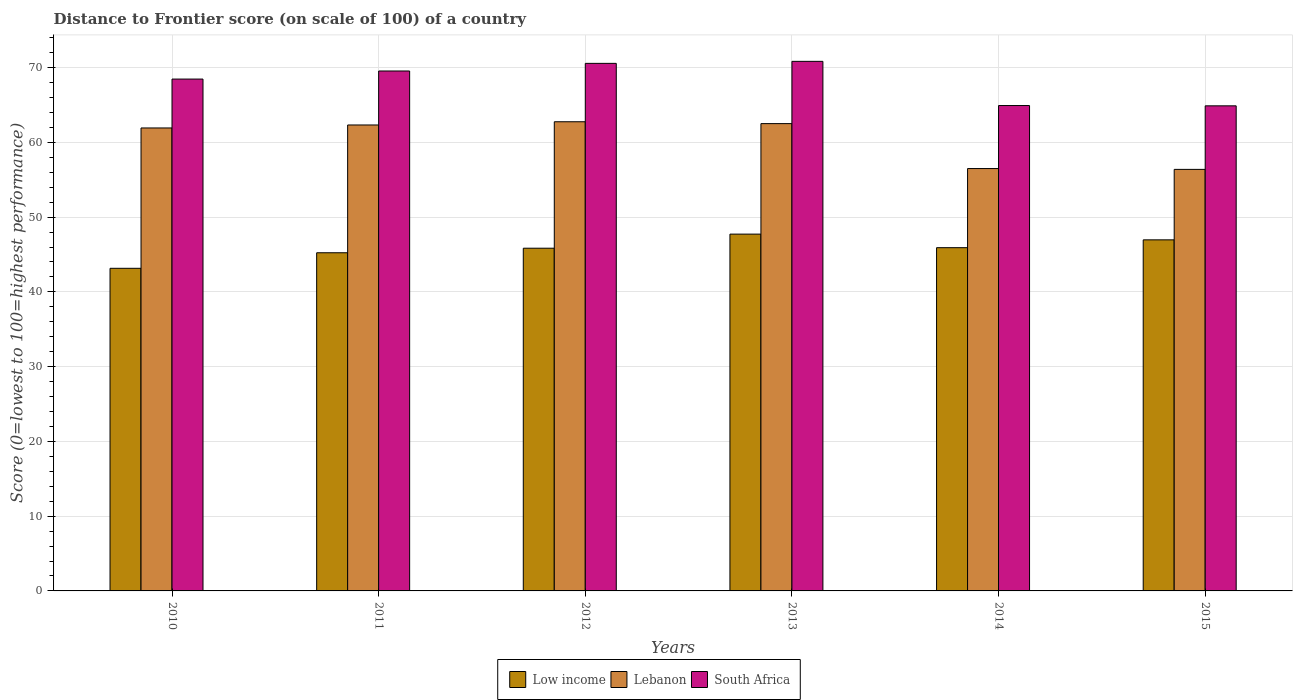How many groups of bars are there?
Keep it short and to the point. 6. How many bars are there on the 2nd tick from the left?
Offer a terse response. 3. How many bars are there on the 5th tick from the right?
Your answer should be compact. 3. What is the label of the 2nd group of bars from the left?
Your answer should be compact. 2011. What is the distance to frontier score of in South Africa in 2012?
Make the answer very short. 70.57. Across all years, what is the maximum distance to frontier score of in South Africa?
Give a very brief answer. 70.84. Across all years, what is the minimum distance to frontier score of in Low income?
Your answer should be compact. 43.16. In which year was the distance to frontier score of in Lebanon minimum?
Offer a terse response. 2015. What is the total distance to frontier score of in Low income in the graph?
Your response must be concise. 274.84. What is the difference between the distance to frontier score of in Low income in 2010 and that in 2012?
Ensure brevity in your answer.  -2.69. What is the difference between the distance to frontier score of in South Africa in 2011 and the distance to frontier score of in Lebanon in 2014?
Your answer should be very brief. 13.05. What is the average distance to frontier score of in Low income per year?
Your answer should be compact. 45.81. In the year 2014, what is the difference between the distance to frontier score of in Lebanon and distance to frontier score of in South Africa?
Keep it short and to the point. -8.43. What is the ratio of the distance to frontier score of in Low income in 2012 to that in 2015?
Give a very brief answer. 0.98. What is the difference between the highest and the lowest distance to frontier score of in Low income?
Offer a terse response. 4.57. What does the 3rd bar from the left in 2012 represents?
Offer a very short reply. South Africa. What does the 1st bar from the right in 2011 represents?
Give a very brief answer. South Africa. How many bars are there?
Provide a short and direct response. 18. Are all the bars in the graph horizontal?
Provide a short and direct response. No. Are the values on the major ticks of Y-axis written in scientific E-notation?
Your response must be concise. No. How many legend labels are there?
Your response must be concise. 3. How are the legend labels stacked?
Make the answer very short. Horizontal. What is the title of the graph?
Make the answer very short. Distance to Frontier score (on scale of 100) of a country. Does "Croatia" appear as one of the legend labels in the graph?
Ensure brevity in your answer.  No. What is the label or title of the Y-axis?
Your answer should be compact. Score (0=lowest to 100=highest performance). What is the Score (0=lowest to 100=highest performance) of Low income in 2010?
Ensure brevity in your answer.  43.16. What is the Score (0=lowest to 100=highest performance) in Lebanon in 2010?
Keep it short and to the point. 61.93. What is the Score (0=lowest to 100=highest performance) in South Africa in 2010?
Provide a succinct answer. 68.47. What is the Score (0=lowest to 100=highest performance) of Low income in 2011?
Provide a short and direct response. 45.24. What is the Score (0=lowest to 100=highest performance) in Lebanon in 2011?
Your response must be concise. 62.33. What is the Score (0=lowest to 100=highest performance) of South Africa in 2011?
Your answer should be very brief. 69.55. What is the Score (0=lowest to 100=highest performance) in Low income in 2012?
Keep it short and to the point. 45.84. What is the Score (0=lowest to 100=highest performance) of Lebanon in 2012?
Give a very brief answer. 62.76. What is the Score (0=lowest to 100=highest performance) in South Africa in 2012?
Offer a terse response. 70.57. What is the Score (0=lowest to 100=highest performance) of Low income in 2013?
Offer a very short reply. 47.73. What is the Score (0=lowest to 100=highest performance) of Lebanon in 2013?
Ensure brevity in your answer.  62.51. What is the Score (0=lowest to 100=highest performance) in South Africa in 2013?
Your response must be concise. 70.84. What is the Score (0=lowest to 100=highest performance) in Low income in 2014?
Your response must be concise. 45.92. What is the Score (0=lowest to 100=highest performance) of Lebanon in 2014?
Provide a short and direct response. 56.5. What is the Score (0=lowest to 100=highest performance) of South Africa in 2014?
Provide a succinct answer. 64.93. What is the Score (0=lowest to 100=highest performance) in Low income in 2015?
Provide a short and direct response. 46.96. What is the Score (0=lowest to 100=highest performance) in Lebanon in 2015?
Provide a succinct answer. 56.39. What is the Score (0=lowest to 100=highest performance) in South Africa in 2015?
Your answer should be very brief. 64.89. Across all years, what is the maximum Score (0=lowest to 100=highest performance) of Low income?
Ensure brevity in your answer.  47.73. Across all years, what is the maximum Score (0=lowest to 100=highest performance) in Lebanon?
Offer a terse response. 62.76. Across all years, what is the maximum Score (0=lowest to 100=highest performance) of South Africa?
Give a very brief answer. 70.84. Across all years, what is the minimum Score (0=lowest to 100=highest performance) in Low income?
Your answer should be very brief. 43.16. Across all years, what is the minimum Score (0=lowest to 100=highest performance) of Lebanon?
Your response must be concise. 56.39. Across all years, what is the minimum Score (0=lowest to 100=highest performance) in South Africa?
Provide a succinct answer. 64.89. What is the total Score (0=lowest to 100=highest performance) of Low income in the graph?
Your response must be concise. 274.84. What is the total Score (0=lowest to 100=highest performance) of Lebanon in the graph?
Your response must be concise. 362.42. What is the total Score (0=lowest to 100=highest performance) in South Africa in the graph?
Offer a terse response. 409.25. What is the difference between the Score (0=lowest to 100=highest performance) of Low income in 2010 and that in 2011?
Offer a terse response. -2.08. What is the difference between the Score (0=lowest to 100=highest performance) in South Africa in 2010 and that in 2011?
Provide a succinct answer. -1.08. What is the difference between the Score (0=lowest to 100=highest performance) in Low income in 2010 and that in 2012?
Your answer should be very brief. -2.69. What is the difference between the Score (0=lowest to 100=highest performance) of Lebanon in 2010 and that in 2012?
Your answer should be compact. -0.83. What is the difference between the Score (0=lowest to 100=highest performance) in South Africa in 2010 and that in 2012?
Your response must be concise. -2.1. What is the difference between the Score (0=lowest to 100=highest performance) of Low income in 2010 and that in 2013?
Make the answer very short. -4.57. What is the difference between the Score (0=lowest to 100=highest performance) in Lebanon in 2010 and that in 2013?
Keep it short and to the point. -0.58. What is the difference between the Score (0=lowest to 100=highest performance) in South Africa in 2010 and that in 2013?
Provide a succinct answer. -2.37. What is the difference between the Score (0=lowest to 100=highest performance) in Low income in 2010 and that in 2014?
Provide a succinct answer. -2.76. What is the difference between the Score (0=lowest to 100=highest performance) of Lebanon in 2010 and that in 2014?
Your answer should be compact. 5.43. What is the difference between the Score (0=lowest to 100=highest performance) of South Africa in 2010 and that in 2014?
Your answer should be compact. 3.54. What is the difference between the Score (0=lowest to 100=highest performance) in Low income in 2010 and that in 2015?
Your response must be concise. -3.81. What is the difference between the Score (0=lowest to 100=highest performance) of Lebanon in 2010 and that in 2015?
Provide a succinct answer. 5.54. What is the difference between the Score (0=lowest to 100=highest performance) of South Africa in 2010 and that in 2015?
Give a very brief answer. 3.58. What is the difference between the Score (0=lowest to 100=highest performance) of Low income in 2011 and that in 2012?
Offer a terse response. -0.61. What is the difference between the Score (0=lowest to 100=highest performance) in Lebanon in 2011 and that in 2012?
Offer a very short reply. -0.43. What is the difference between the Score (0=lowest to 100=highest performance) in South Africa in 2011 and that in 2012?
Offer a very short reply. -1.02. What is the difference between the Score (0=lowest to 100=highest performance) in Low income in 2011 and that in 2013?
Your answer should be very brief. -2.49. What is the difference between the Score (0=lowest to 100=highest performance) of Lebanon in 2011 and that in 2013?
Your response must be concise. -0.18. What is the difference between the Score (0=lowest to 100=highest performance) in South Africa in 2011 and that in 2013?
Your answer should be very brief. -1.29. What is the difference between the Score (0=lowest to 100=highest performance) in Low income in 2011 and that in 2014?
Keep it short and to the point. -0.68. What is the difference between the Score (0=lowest to 100=highest performance) of Lebanon in 2011 and that in 2014?
Provide a short and direct response. 5.83. What is the difference between the Score (0=lowest to 100=highest performance) of South Africa in 2011 and that in 2014?
Provide a succinct answer. 4.62. What is the difference between the Score (0=lowest to 100=highest performance) in Low income in 2011 and that in 2015?
Your answer should be very brief. -1.73. What is the difference between the Score (0=lowest to 100=highest performance) in Lebanon in 2011 and that in 2015?
Offer a terse response. 5.94. What is the difference between the Score (0=lowest to 100=highest performance) in South Africa in 2011 and that in 2015?
Ensure brevity in your answer.  4.66. What is the difference between the Score (0=lowest to 100=highest performance) of Low income in 2012 and that in 2013?
Keep it short and to the point. -1.89. What is the difference between the Score (0=lowest to 100=highest performance) of Lebanon in 2012 and that in 2013?
Your answer should be compact. 0.25. What is the difference between the Score (0=lowest to 100=highest performance) in South Africa in 2012 and that in 2013?
Offer a very short reply. -0.27. What is the difference between the Score (0=lowest to 100=highest performance) of Low income in 2012 and that in 2014?
Provide a succinct answer. -0.07. What is the difference between the Score (0=lowest to 100=highest performance) of Lebanon in 2012 and that in 2014?
Keep it short and to the point. 6.26. What is the difference between the Score (0=lowest to 100=highest performance) in South Africa in 2012 and that in 2014?
Your response must be concise. 5.64. What is the difference between the Score (0=lowest to 100=highest performance) of Low income in 2012 and that in 2015?
Offer a terse response. -1.12. What is the difference between the Score (0=lowest to 100=highest performance) of Lebanon in 2012 and that in 2015?
Your answer should be compact. 6.37. What is the difference between the Score (0=lowest to 100=highest performance) in South Africa in 2012 and that in 2015?
Your answer should be very brief. 5.68. What is the difference between the Score (0=lowest to 100=highest performance) of Low income in 2013 and that in 2014?
Your answer should be very brief. 1.81. What is the difference between the Score (0=lowest to 100=highest performance) of Lebanon in 2013 and that in 2014?
Provide a succinct answer. 6.01. What is the difference between the Score (0=lowest to 100=highest performance) of South Africa in 2013 and that in 2014?
Offer a terse response. 5.91. What is the difference between the Score (0=lowest to 100=highest performance) in Low income in 2013 and that in 2015?
Provide a succinct answer. 0.77. What is the difference between the Score (0=lowest to 100=highest performance) in Lebanon in 2013 and that in 2015?
Provide a succinct answer. 6.12. What is the difference between the Score (0=lowest to 100=highest performance) in South Africa in 2013 and that in 2015?
Give a very brief answer. 5.95. What is the difference between the Score (0=lowest to 100=highest performance) in Low income in 2014 and that in 2015?
Your answer should be compact. -1.05. What is the difference between the Score (0=lowest to 100=highest performance) in Lebanon in 2014 and that in 2015?
Your answer should be very brief. 0.11. What is the difference between the Score (0=lowest to 100=highest performance) of South Africa in 2014 and that in 2015?
Your answer should be very brief. 0.04. What is the difference between the Score (0=lowest to 100=highest performance) of Low income in 2010 and the Score (0=lowest to 100=highest performance) of Lebanon in 2011?
Offer a very short reply. -19.17. What is the difference between the Score (0=lowest to 100=highest performance) of Low income in 2010 and the Score (0=lowest to 100=highest performance) of South Africa in 2011?
Your answer should be compact. -26.39. What is the difference between the Score (0=lowest to 100=highest performance) in Lebanon in 2010 and the Score (0=lowest to 100=highest performance) in South Africa in 2011?
Ensure brevity in your answer.  -7.62. What is the difference between the Score (0=lowest to 100=highest performance) of Low income in 2010 and the Score (0=lowest to 100=highest performance) of Lebanon in 2012?
Ensure brevity in your answer.  -19.6. What is the difference between the Score (0=lowest to 100=highest performance) of Low income in 2010 and the Score (0=lowest to 100=highest performance) of South Africa in 2012?
Make the answer very short. -27.41. What is the difference between the Score (0=lowest to 100=highest performance) in Lebanon in 2010 and the Score (0=lowest to 100=highest performance) in South Africa in 2012?
Make the answer very short. -8.64. What is the difference between the Score (0=lowest to 100=highest performance) in Low income in 2010 and the Score (0=lowest to 100=highest performance) in Lebanon in 2013?
Your answer should be compact. -19.35. What is the difference between the Score (0=lowest to 100=highest performance) of Low income in 2010 and the Score (0=lowest to 100=highest performance) of South Africa in 2013?
Your answer should be very brief. -27.68. What is the difference between the Score (0=lowest to 100=highest performance) of Lebanon in 2010 and the Score (0=lowest to 100=highest performance) of South Africa in 2013?
Your response must be concise. -8.91. What is the difference between the Score (0=lowest to 100=highest performance) in Low income in 2010 and the Score (0=lowest to 100=highest performance) in Lebanon in 2014?
Your response must be concise. -13.34. What is the difference between the Score (0=lowest to 100=highest performance) of Low income in 2010 and the Score (0=lowest to 100=highest performance) of South Africa in 2014?
Your answer should be very brief. -21.77. What is the difference between the Score (0=lowest to 100=highest performance) of Lebanon in 2010 and the Score (0=lowest to 100=highest performance) of South Africa in 2014?
Your answer should be compact. -3. What is the difference between the Score (0=lowest to 100=highest performance) of Low income in 2010 and the Score (0=lowest to 100=highest performance) of Lebanon in 2015?
Make the answer very short. -13.23. What is the difference between the Score (0=lowest to 100=highest performance) in Low income in 2010 and the Score (0=lowest to 100=highest performance) in South Africa in 2015?
Your response must be concise. -21.73. What is the difference between the Score (0=lowest to 100=highest performance) in Lebanon in 2010 and the Score (0=lowest to 100=highest performance) in South Africa in 2015?
Your response must be concise. -2.96. What is the difference between the Score (0=lowest to 100=highest performance) of Low income in 2011 and the Score (0=lowest to 100=highest performance) of Lebanon in 2012?
Offer a very short reply. -17.52. What is the difference between the Score (0=lowest to 100=highest performance) of Low income in 2011 and the Score (0=lowest to 100=highest performance) of South Africa in 2012?
Provide a short and direct response. -25.33. What is the difference between the Score (0=lowest to 100=highest performance) of Lebanon in 2011 and the Score (0=lowest to 100=highest performance) of South Africa in 2012?
Keep it short and to the point. -8.24. What is the difference between the Score (0=lowest to 100=highest performance) in Low income in 2011 and the Score (0=lowest to 100=highest performance) in Lebanon in 2013?
Keep it short and to the point. -17.27. What is the difference between the Score (0=lowest to 100=highest performance) in Low income in 2011 and the Score (0=lowest to 100=highest performance) in South Africa in 2013?
Your answer should be compact. -25.6. What is the difference between the Score (0=lowest to 100=highest performance) in Lebanon in 2011 and the Score (0=lowest to 100=highest performance) in South Africa in 2013?
Keep it short and to the point. -8.51. What is the difference between the Score (0=lowest to 100=highest performance) in Low income in 2011 and the Score (0=lowest to 100=highest performance) in Lebanon in 2014?
Offer a terse response. -11.26. What is the difference between the Score (0=lowest to 100=highest performance) in Low income in 2011 and the Score (0=lowest to 100=highest performance) in South Africa in 2014?
Provide a succinct answer. -19.69. What is the difference between the Score (0=lowest to 100=highest performance) of Lebanon in 2011 and the Score (0=lowest to 100=highest performance) of South Africa in 2014?
Your response must be concise. -2.6. What is the difference between the Score (0=lowest to 100=highest performance) of Low income in 2011 and the Score (0=lowest to 100=highest performance) of Lebanon in 2015?
Your answer should be compact. -11.15. What is the difference between the Score (0=lowest to 100=highest performance) of Low income in 2011 and the Score (0=lowest to 100=highest performance) of South Africa in 2015?
Provide a succinct answer. -19.65. What is the difference between the Score (0=lowest to 100=highest performance) of Lebanon in 2011 and the Score (0=lowest to 100=highest performance) of South Africa in 2015?
Keep it short and to the point. -2.56. What is the difference between the Score (0=lowest to 100=highest performance) in Low income in 2012 and the Score (0=lowest to 100=highest performance) in Lebanon in 2013?
Offer a very short reply. -16.67. What is the difference between the Score (0=lowest to 100=highest performance) of Low income in 2012 and the Score (0=lowest to 100=highest performance) of South Africa in 2013?
Give a very brief answer. -25. What is the difference between the Score (0=lowest to 100=highest performance) of Lebanon in 2012 and the Score (0=lowest to 100=highest performance) of South Africa in 2013?
Keep it short and to the point. -8.08. What is the difference between the Score (0=lowest to 100=highest performance) in Low income in 2012 and the Score (0=lowest to 100=highest performance) in Lebanon in 2014?
Keep it short and to the point. -10.66. What is the difference between the Score (0=lowest to 100=highest performance) in Low income in 2012 and the Score (0=lowest to 100=highest performance) in South Africa in 2014?
Provide a succinct answer. -19.09. What is the difference between the Score (0=lowest to 100=highest performance) in Lebanon in 2012 and the Score (0=lowest to 100=highest performance) in South Africa in 2014?
Give a very brief answer. -2.17. What is the difference between the Score (0=lowest to 100=highest performance) of Low income in 2012 and the Score (0=lowest to 100=highest performance) of Lebanon in 2015?
Your response must be concise. -10.55. What is the difference between the Score (0=lowest to 100=highest performance) in Low income in 2012 and the Score (0=lowest to 100=highest performance) in South Africa in 2015?
Your answer should be very brief. -19.05. What is the difference between the Score (0=lowest to 100=highest performance) of Lebanon in 2012 and the Score (0=lowest to 100=highest performance) of South Africa in 2015?
Make the answer very short. -2.13. What is the difference between the Score (0=lowest to 100=highest performance) of Low income in 2013 and the Score (0=lowest to 100=highest performance) of Lebanon in 2014?
Ensure brevity in your answer.  -8.77. What is the difference between the Score (0=lowest to 100=highest performance) of Low income in 2013 and the Score (0=lowest to 100=highest performance) of South Africa in 2014?
Your response must be concise. -17.2. What is the difference between the Score (0=lowest to 100=highest performance) of Lebanon in 2013 and the Score (0=lowest to 100=highest performance) of South Africa in 2014?
Give a very brief answer. -2.42. What is the difference between the Score (0=lowest to 100=highest performance) in Low income in 2013 and the Score (0=lowest to 100=highest performance) in Lebanon in 2015?
Make the answer very short. -8.66. What is the difference between the Score (0=lowest to 100=highest performance) of Low income in 2013 and the Score (0=lowest to 100=highest performance) of South Africa in 2015?
Offer a very short reply. -17.16. What is the difference between the Score (0=lowest to 100=highest performance) of Lebanon in 2013 and the Score (0=lowest to 100=highest performance) of South Africa in 2015?
Ensure brevity in your answer.  -2.38. What is the difference between the Score (0=lowest to 100=highest performance) of Low income in 2014 and the Score (0=lowest to 100=highest performance) of Lebanon in 2015?
Offer a terse response. -10.47. What is the difference between the Score (0=lowest to 100=highest performance) in Low income in 2014 and the Score (0=lowest to 100=highest performance) in South Africa in 2015?
Keep it short and to the point. -18.97. What is the difference between the Score (0=lowest to 100=highest performance) in Lebanon in 2014 and the Score (0=lowest to 100=highest performance) in South Africa in 2015?
Offer a very short reply. -8.39. What is the average Score (0=lowest to 100=highest performance) of Low income per year?
Your answer should be very brief. 45.81. What is the average Score (0=lowest to 100=highest performance) of Lebanon per year?
Give a very brief answer. 60.4. What is the average Score (0=lowest to 100=highest performance) in South Africa per year?
Keep it short and to the point. 68.21. In the year 2010, what is the difference between the Score (0=lowest to 100=highest performance) of Low income and Score (0=lowest to 100=highest performance) of Lebanon?
Provide a succinct answer. -18.77. In the year 2010, what is the difference between the Score (0=lowest to 100=highest performance) in Low income and Score (0=lowest to 100=highest performance) in South Africa?
Your answer should be compact. -25.31. In the year 2010, what is the difference between the Score (0=lowest to 100=highest performance) in Lebanon and Score (0=lowest to 100=highest performance) in South Africa?
Your answer should be very brief. -6.54. In the year 2011, what is the difference between the Score (0=lowest to 100=highest performance) of Low income and Score (0=lowest to 100=highest performance) of Lebanon?
Offer a terse response. -17.09. In the year 2011, what is the difference between the Score (0=lowest to 100=highest performance) of Low income and Score (0=lowest to 100=highest performance) of South Africa?
Offer a terse response. -24.31. In the year 2011, what is the difference between the Score (0=lowest to 100=highest performance) in Lebanon and Score (0=lowest to 100=highest performance) in South Africa?
Provide a short and direct response. -7.22. In the year 2012, what is the difference between the Score (0=lowest to 100=highest performance) in Low income and Score (0=lowest to 100=highest performance) in Lebanon?
Provide a succinct answer. -16.92. In the year 2012, what is the difference between the Score (0=lowest to 100=highest performance) in Low income and Score (0=lowest to 100=highest performance) in South Africa?
Provide a succinct answer. -24.73. In the year 2012, what is the difference between the Score (0=lowest to 100=highest performance) of Lebanon and Score (0=lowest to 100=highest performance) of South Africa?
Keep it short and to the point. -7.81. In the year 2013, what is the difference between the Score (0=lowest to 100=highest performance) in Low income and Score (0=lowest to 100=highest performance) in Lebanon?
Offer a very short reply. -14.78. In the year 2013, what is the difference between the Score (0=lowest to 100=highest performance) of Low income and Score (0=lowest to 100=highest performance) of South Africa?
Your response must be concise. -23.11. In the year 2013, what is the difference between the Score (0=lowest to 100=highest performance) of Lebanon and Score (0=lowest to 100=highest performance) of South Africa?
Offer a very short reply. -8.33. In the year 2014, what is the difference between the Score (0=lowest to 100=highest performance) in Low income and Score (0=lowest to 100=highest performance) in Lebanon?
Keep it short and to the point. -10.58. In the year 2014, what is the difference between the Score (0=lowest to 100=highest performance) of Low income and Score (0=lowest to 100=highest performance) of South Africa?
Keep it short and to the point. -19.01. In the year 2014, what is the difference between the Score (0=lowest to 100=highest performance) in Lebanon and Score (0=lowest to 100=highest performance) in South Africa?
Your answer should be very brief. -8.43. In the year 2015, what is the difference between the Score (0=lowest to 100=highest performance) in Low income and Score (0=lowest to 100=highest performance) in Lebanon?
Offer a terse response. -9.43. In the year 2015, what is the difference between the Score (0=lowest to 100=highest performance) of Low income and Score (0=lowest to 100=highest performance) of South Africa?
Give a very brief answer. -17.93. In the year 2015, what is the difference between the Score (0=lowest to 100=highest performance) of Lebanon and Score (0=lowest to 100=highest performance) of South Africa?
Give a very brief answer. -8.5. What is the ratio of the Score (0=lowest to 100=highest performance) of Low income in 2010 to that in 2011?
Provide a succinct answer. 0.95. What is the ratio of the Score (0=lowest to 100=highest performance) in South Africa in 2010 to that in 2011?
Keep it short and to the point. 0.98. What is the ratio of the Score (0=lowest to 100=highest performance) of Low income in 2010 to that in 2012?
Make the answer very short. 0.94. What is the ratio of the Score (0=lowest to 100=highest performance) in South Africa in 2010 to that in 2012?
Your response must be concise. 0.97. What is the ratio of the Score (0=lowest to 100=highest performance) of Low income in 2010 to that in 2013?
Keep it short and to the point. 0.9. What is the ratio of the Score (0=lowest to 100=highest performance) of Lebanon in 2010 to that in 2013?
Give a very brief answer. 0.99. What is the ratio of the Score (0=lowest to 100=highest performance) of South Africa in 2010 to that in 2013?
Offer a terse response. 0.97. What is the ratio of the Score (0=lowest to 100=highest performance) in Low income in 2010 to that in 2014?
Keep it short and to the point. 0.94. What is the ratio of the Score (0=lowest to 100=highest performance) in Lebanon in 2010 to that in 2014?
Make the answer very short. 1.1. What is the ratio of the Score (0=lowest to 100=highest performance) in South Africa in 2010 to that in 2014?
Keep it short and to the point. 1.05. What is the ratio of the Score (0=lowest to 100=highest performance) in Low income in 2010 to that in 2015?
Offer a terse response. 0.92. What is the ratio of the Score (0=lowest to 100=highest performance) in Lebanon in 2010 to that in 2015?
Offer a terse response. 1.1. What is the ratio of the Score (0=lowest to 100=highest performance) of South Africa in 2010 to that in 2015?
Your answer should be very brief. 1.06. What is the ratio of the Score (0=lowest to 100=highest performance) in Low income in 2011 to that in 2012?
Keep it short and to the point. 0.99. What is the ratio of the Score (0=lowest to 100=highest performance) of South Africa in 2011 to that in 2012?
Your response must be concise. 0.99. What is the ratio of the Score (0=lowest to 100=highest performance) of Low income in 2011 to that in 2013?
Make the answer very short. 0.95. What is the ratio of the Score (0=lowest to 100=highest performance) of Lebanon in 2011 to that in 2013?
Ensure brevity in your answer.  1. What is the ratio of the Score (0=lowest to 100=highest performance) in South Africa in 2011 to that in 2013?
Keep it short and to the point. 0.98. What is the ratio of the Score (0=lowest to 100=highest performance) of Low income in 2011 to that in 2014?
Your response must be concise. 0.99. What is the ratio of the Score (0=lowest to 100=highest performance) in Lebanon in 2011 to that in 2014?
Your response must be concise. 1.1. What is the ratio of the Score (0=lowest to 100=highest performance) in South Africa in 2011 to that in 2014?
Offer a very short reply. 1.07. What is the ratio of the Score (0=lowest to 100=highest performance) of Low income in 2011 to that in 2015?
Provide a succinct answer. 0.96. What is the ratio of the Score (0=lowest to 100=highest performance) in Lebanon in 2011 to that in 2015?
Offer a very short reply. 1.11. What is the ratio of the Score (0=lowest to 100=highest performance) in South Africa in 2011 to that in 2015?
Offer a very short reply. 1.07. What is the ratio of the Score (0=lowest to 100=highest performance) in Low income in 2012 to that in 2013?
Your answer should be very brief. 0.96. What is the ratio of the Score (0=lowest to 100=highest performance) in Lebanon in 2012 to that in 2013?
Provide a succinct answer. 1. What is the ratio of the Score (0=lowest to 100=highest performance) in South Africa in 2012 to that in 2013?
Your answer should be compact. 1. What is the ratio of the Score (0=lowest to 100=highest performance) of Lebanon in 2012 to that in 2014?
Provide a succinct answer. 1.11. What is the ratio of the Score (0=lowest to 100=highest performance) of South Africa in 2012 to that in 2014?
Offer a very short reply. 1.09. What is the ratio of the Score (0=lowest to 100=highest performance) of Low income in 2012 to that in 2015?
Provide a succinct answer. 0.98. What is the ratio of the Score (0=lowest to 100=highest performance) in Lebanon in 2012 to that in 2015?
Provide a short and direct response. 1.11. What is the ratio of the Score (0=lowest to 100=highest performance) of South Africa in 2012 to that in 2015?
Your answer should be compact. 1.09. What is the ratio of the Score (0=lowest to 100=highest performance) of Low income in 2013 to that in 2014?
Keep it short and to the point. 1.04. What is the ratio of the Score (0=lowest to 100=highest performance) of Lebanon in 2013 to that in 2014?
Make the answer very short. 1.11. What is the ratio of the Score (0=lowest to 100=highest performance) of South Africa in 2013 to that in 2014?
Make the answer very short. 1.09. What is the ratio of the Score (0=lowest to 100=highest performance) in Low income in 2013 to that in 2015?
Your answer should be very brief. 1.02. What is the ratio of the Score (0=lowest to 100=highest performance) in Lebanon in 2013 to that in 2015?
Offer a very short reply. 1.11. What is the ratio of the Score (0=lowest to 100=highest performance) in South Africa in 2013 to that in 2015?
Your response must be concise. 1.09. What is the ratio of the Score (0=lowest to 100=highest performance) of Low income in 2014 to that in 2015?
Offer a very short reply. 0.98. What is the difference between the highest and the second highest Score (0=lowest to 100=highest performance) in Low income?
Your response must be concise. 0.77. What is the difference between the highest and the second highest Score (0=lowest to 100=highest performance) of Lebanon?
Offer a very short reply. 0.25. What is the difference between the highest and the second highest Score (0=lowest to 100=highest performance) of South Africa?
Your response must be concise. 0.27. What is the difference between the highest and the lowest Score (0=lowest to 100=highest performance) of Low income?
Keep it short and to the point. 4.57. What is the difference between the highest and the lowest Score (0=lowest to 100=highest performance) of Lebanon?
Give a very brief answer. 6.37. What is the difference between the highest and the lowest Score (0=lowest to 100=highest performance) in South Africa?
Ensure brevity in your answer.  5.95. 